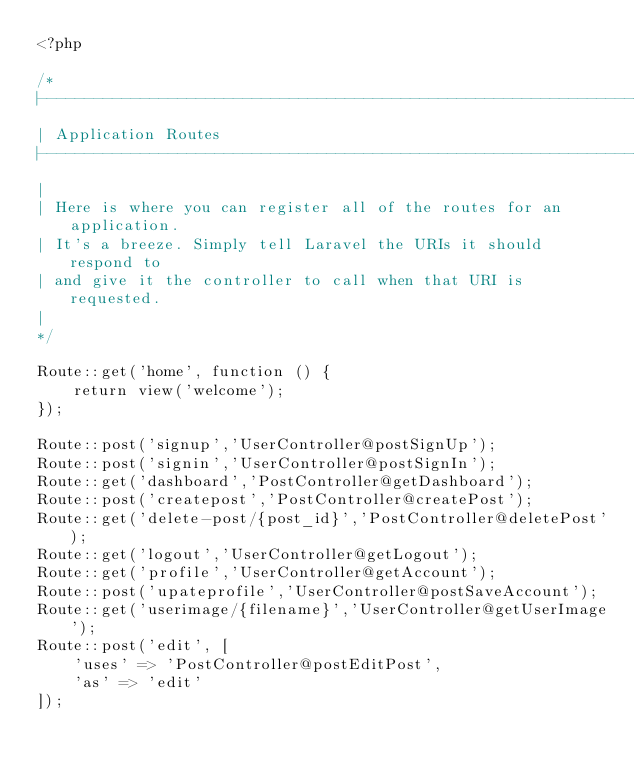Convert code to text. <code><loc_0><loc_0><loc_500><loc_500><_PHP_><?php

/*
|--------------------------------------------------------------------------
| Application Routes
|--------------------------------------------------------------------------
|
| Here is where you can register all of the routes for an application.
| It's a breeze. Simply tell Laravel the URIs it should respond to
| and give it the controller to call when that URI is requested.
|
*/

Route::get('home', function () {
    return view('welcome');
});

Route::post('signup','UserController@postSignUp');
Route::post('signin','UserController@postSignIn');
Route::get('dashboard','PostController@getDashboard');
Route::post('createpost','PostController@createPost');
Route::get('delete-post/{post_id}','PostController@deletePost');
Route::get('logout','UserController@getLogout');
Route::get('profile','UserController@getAccount');
Route::post('upateprofile','UserController@postSaveAccount');
Route::get('userimage/{filename}','UserController@getUserImage');
Route::post('edit', [
    'uses' => 'PostController@postEditPost',
    'as' => 'edit'
]);
</code> 